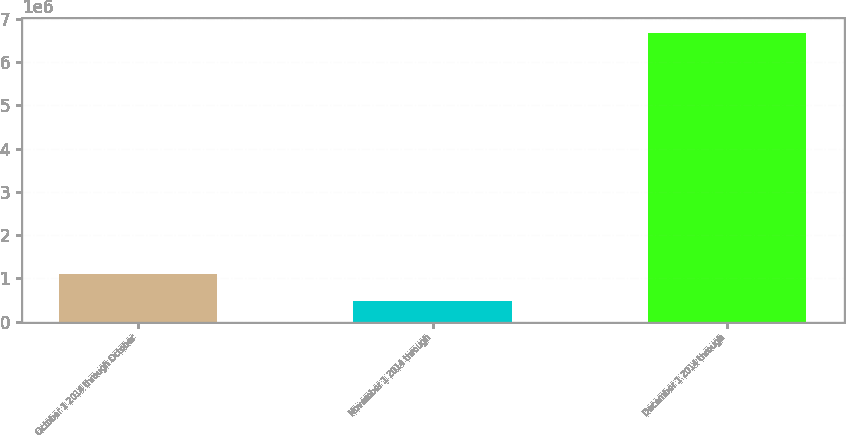<chart> <loc_0><loc_0><loc_500><loc_500><bar_chart><fcel>October 1 2014 through October<fcel>November 1 2014 through<fcel>December 1 2014 through<nl><fcel>1.09909e+06<fcel>479830<fcel>6.67247e+06<nl></chart> 